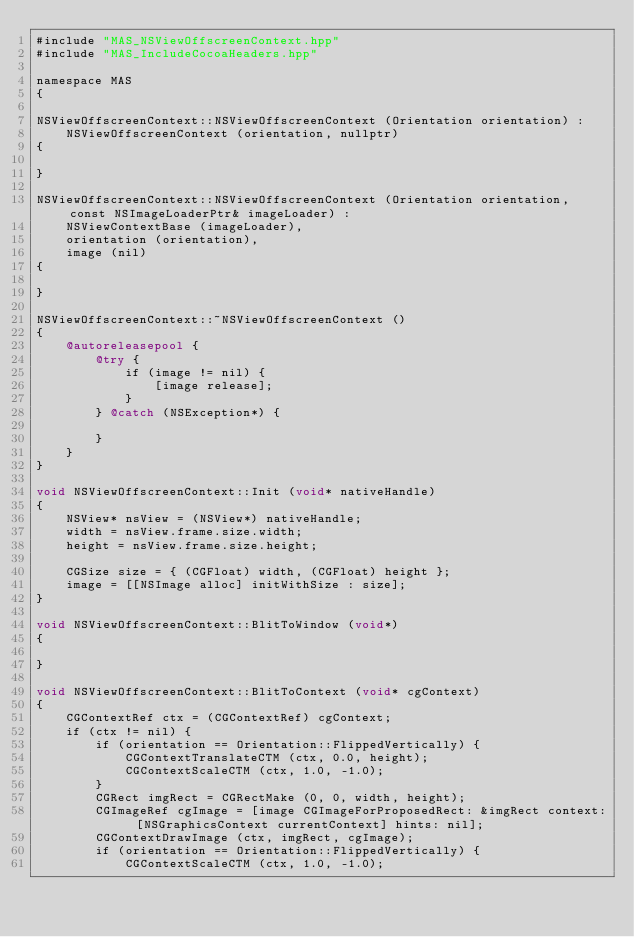Convert code to text. <code><loc_0><loc_0><loc_500><loc_500><_ObjectiveC_>#include "MAS_NSViewOffscreenContext.hpp"
#include "MAS_IncludeCocoaHeaders.hpp"

namespace MAS
{

NSViewOffscreenContext::NSViewOffscreenContext (Orientation orientation) :
	NSViewOffscreenContext (orientation, nullptr)
{

}

NSViewOffscreenContext::NSViewOffscreenContext (Orientation orientation, const NSImageLoaderPtr& imageLoader) :
	NSViewContextBase (imageLoader),
	orientation (orientation),
	image (nil)
{

}

NSViewOffscreenContext::~NSViewOffscreenContext ()
{
	@autoreleasepool {
		@try {
			if (image != nil) {
				[image release];
			}
		} @catch (NSException*) {
			
		}
	}
}

void NSViewOffscreenContext::Init (void* nativeHandle)
{
	NSView* nsView = (NSView*) nativeHandle;
	width = nsView.frame.size.width;
	height = nsView.frame.size.height;
	
	CGSize size = { (CGFloat) width, (CGFloat) height };
	image = [[NSImage alloc] initWithSize : size];
}

void NSViewOffscreenContext::BlitToWindow (void*)
{
	
}

void NSViewOffscreenContext::BlitToContext (void* cgContext)
{
	CGContextRef ctx = (CGContextRef) cgContext;
	if (ctx != nil) {
		if (orientation == Orientation::FlippedVertically) {
			CGContextTranslateCTM (ctx, 0.0, height);
			CGContextScaleCTM (ctx, 1.0, -1.0);
		}
		CGRect imgRect = CGRectMake (0, 0, width, height);
		CGImageRef cgImage = [image CGImageForProposedRect: &imgRect context: [NSGraphicsContext currentContext] hints: nil];
		CGContextDrawImage (ctx, imgRect, cgImage);
		if (orientation == Orientation::FlippedVertically) {
			CGContextScaleCTM (ctx, 1.0, -1.0);</code> 